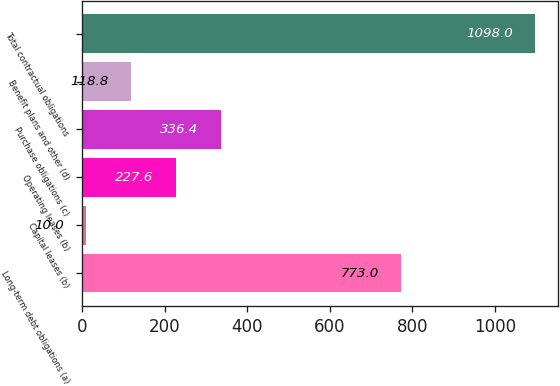<chart> <loc_0><loc_0><loc_500><loc_500><bar_chart><fcel>Long-term debt obligations (a)<fcel>Capital leases (b)<fcel>Operating leases (b)<fcel>Purchase obligations (c)<fcel>Benefit plans and other (d)<fcel>Total contractual obligations<nl><fcel>773<fcel>10<fcel>227.6<fcel>336.4<fcel>118.8<fcel>1098<nl></chart> 